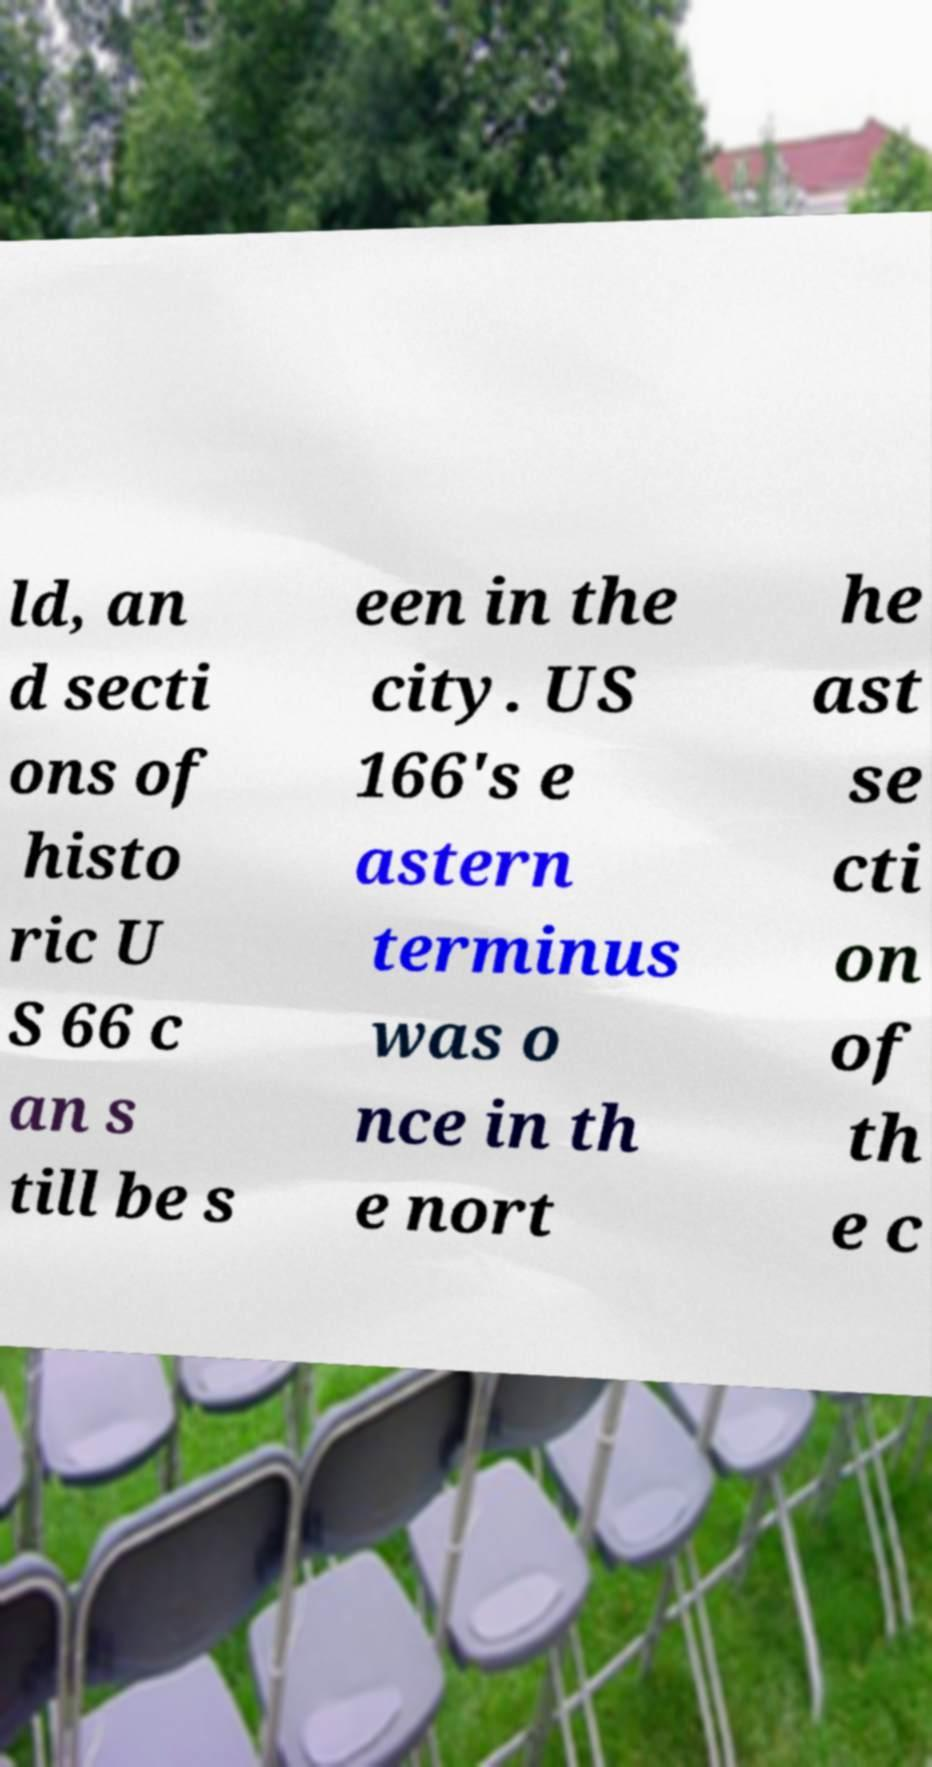There's text embedded in this image that I need extracted. Can you transcribe it verbatim? ld, an d secti ons of histo ric U S 66 c an s till be s een in the city. US 166's e astern terminus was o nce in th e nort he ast se cti on of th e c 